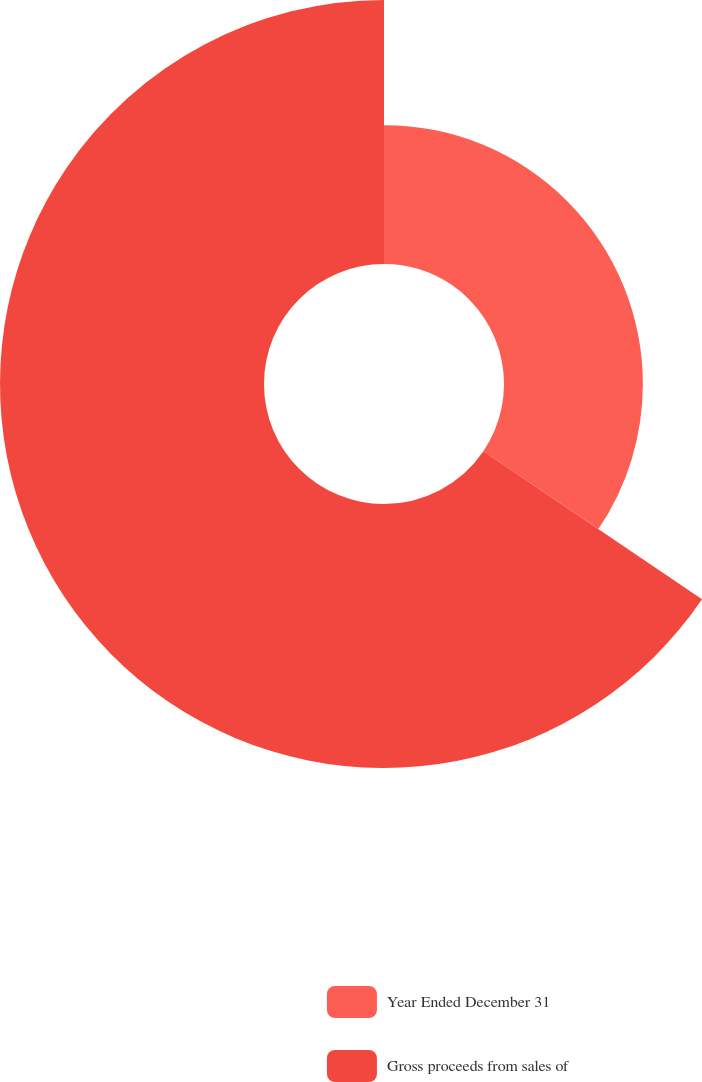Convert chart. <chart><loc_0><loc_0><loc_500><loc_500><pie_chart><fcel>Year Ended December 31<fcel>Gross proceeds from sales of<nl><fcel>34.47%<fcel>65.53%<nl></chart> 